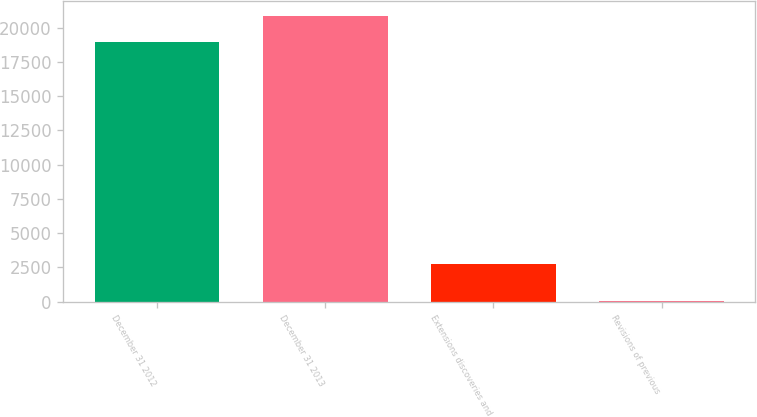Convert chart. <chart><loc_0><loc_0><loc_500><loc_500><bar_chart><fcel>December 31 2012<fcel>December 31 2013<fcel>Extensions discoveries and<fcel>Revisions of previous<nl><fcel>18985<fcel>20880.6<fcel>2750<fcel>32<nl></chart> 